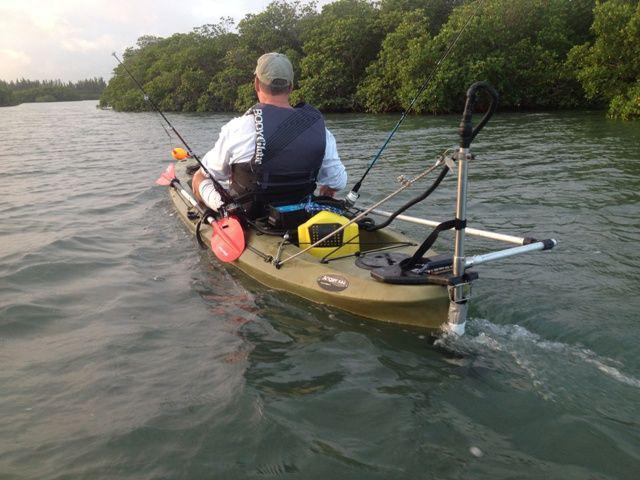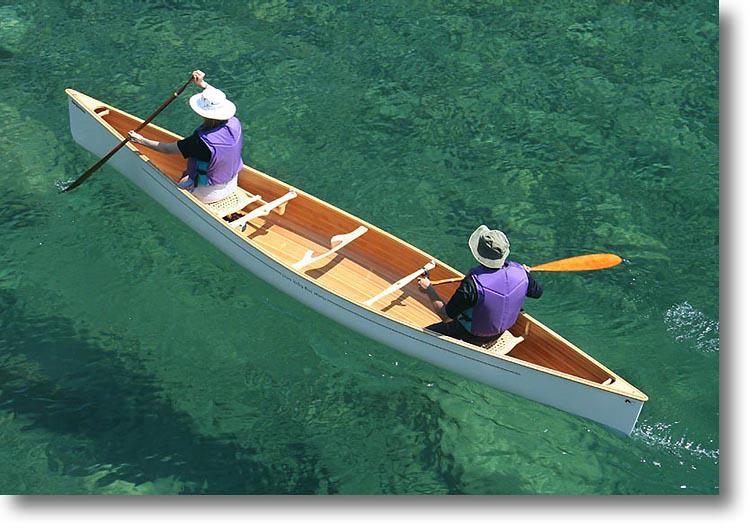The first image is the image on the left, the second image is the image on the right. Examine the images to the left and right. Is the description "There are three or less people in boats" accurate? Answer yes or no. Yes. The first image is the image on the left, the second image is the image on the right. Evaluate the accuracy of this statement regarding the images: "Atleast one image has more than one boat". Is it true? Answer yes or no. No. 